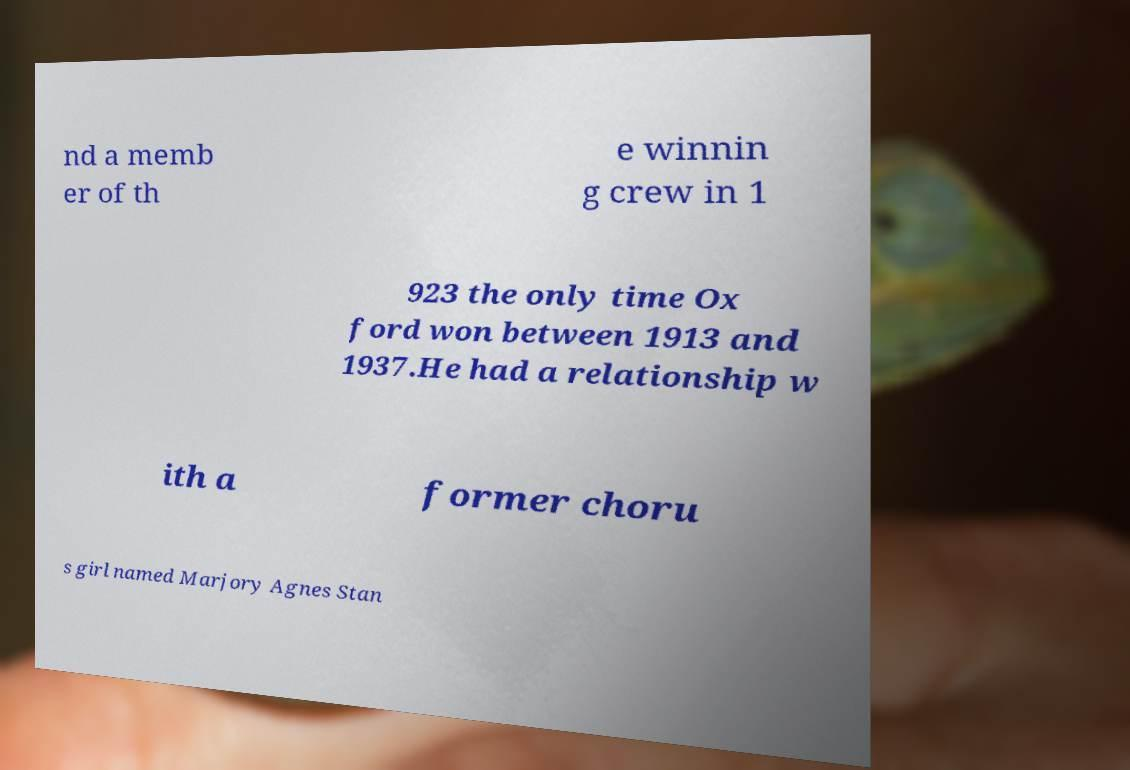What messages or text are displayed in this image? I need them in a readable, typed format. nd a memb er of th e winnin g crew in 1 923 the only time Ox ford won between 1913 and 1937.He had a relationship w ith a former choru s girl named Marjory Agnes Stan 